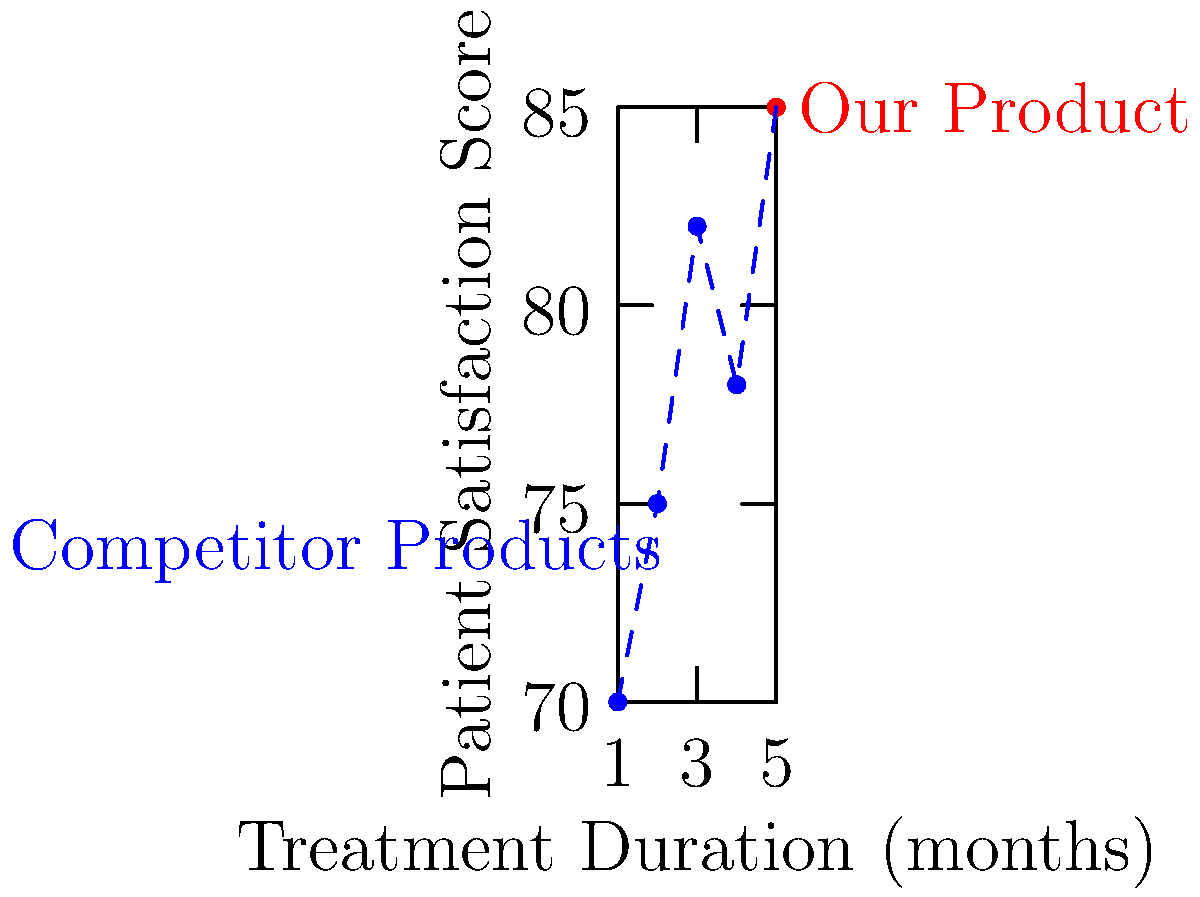Based on the scatter plot of patient satisfaction scores for various treatments, what conclusion can be drawn about our product's performance compared to competitor products? To interpret the scatter plot and draw a conclusion about our product's performance:

1. Identify our product: The red dot represents our product.
2. Locate competitor products: The blue dots represent competitor products.
3. Compare satisfaction scores:
   - Our product: 85 (y-axis value for the red dot)
   - Highest competitor score: 82 (highest y-axis value among blue dots)
4. Compare treatment duration:
   - Our product: 5 months (x-axis value for the red dot)
   - Competitor range: 1-4 months (x-axis values for blue dots)
5. Analyze the trend:
   - Overall, there's a general upward trend in satisfaction as treatment duration increases.
   - Our product has the longest duration and highest satisfaction score.

Conclusion: Our product outperforms competitors with the highest patient satisfaction score (85) and longest treatment duration (5 months), indicating superior efficacy and patient experience.
Answer: Superior performance with highest satisfaction score and longest treatment duration. 